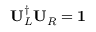<formula> <loc_0><loc_0><loc_500><loc_500>U _ { L } ^ { \dagger } U _ { R } = 1</formula> 